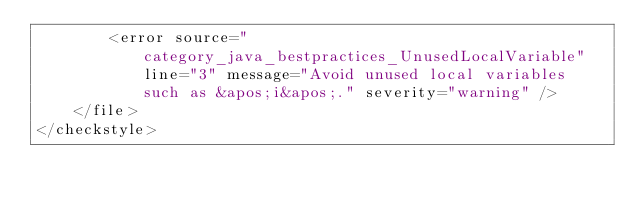<code> <loc_0><loc_0><loc_500><loc_500><_XML_>        <error source="category_java_bestpractices_UnusedLocalVariable" line="3" message="Avoid unused local variables such as &apos;i&apos;." severity="warning" />
    </file>
</checkstyle>
</code> 